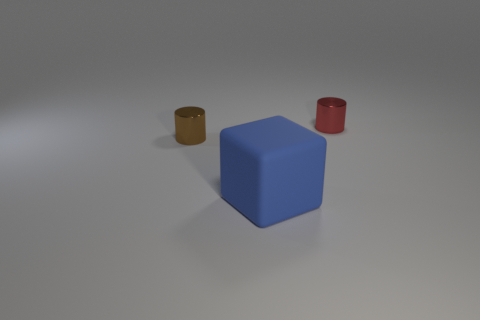The small cylinder to the left of the tiny shiny object to the right of the matte cube is made of what material?
Offer a very short reply. Metal. What number of objects are tiny gray metal balls or brown things?
Provide a short and direct response. 1. Are there fewer small red cylinders than tiny metallic objects?
Ensure brevity in your answer.  Yes. There is a thing that is made of the same material as the tiny brown cylinder; what size is it?
Provide a short and direct response. Small. The blue rubber thing is what size?
Offer a very short reply. Large. What is the shape of the large blue thing?
Your response must be concise. Cube. There is a small cylinder on the right side of the big rubber object; is it the same color as the rubber cube?
Keep it short and to the point. No. What is the size of the other object that is the same shape as the red object?
Ensure brevity in your answer.  Small. Are there any other things that have the same material as the large blue object?
Your response must be concise. No. Is there a brown metal object on the right side of the metallic cylinder to the right of the rubber thing to the right of the brown shiny cylinder?
Your answer should be very brief. No. 